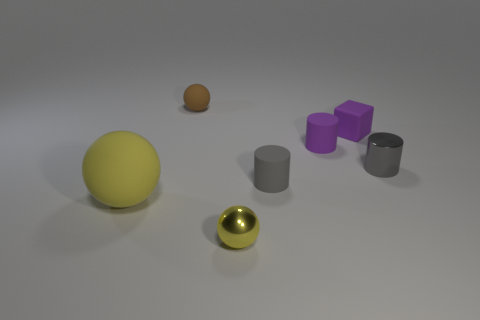There is a metallic thing right of the yellow object to the right of the brown object; what color is it?
Your answer should be very brief. Gray. Is there anything else that has the same shape as the large yellow rubber object?
Keep it short and to the point. Yes. Is the number of tiny purple cylinders that are to the left of the large matte ball the same as the number of small cylinders that are behind the metal cylinder?
Offer a very short reply. No. How many cylinders are tiny gray things or tiny yellow metallic things?
Ensure brevity in your answer.  2. How many other objects are there of the same material as the large object?
Your answer should be very brief. 4. There is a tiny metallic object to the right of the small yellow metallic sphere; what is its shape?
Your answer should be compact. Cylinder. There is a yellow sphere that is to the left of the tiny ball that is in front of the large object; what is its material?
Ensure brevity in your answer.  Rubber. Is the number of yellow spheres to the left of the matte block greater than the number of tiny brown shiny things?
Your response must be concise. Yes. How many other objects are the same color as the small rubber cube?
Provide a short and direct response. 1. What shape is the gray shiny thing that is the same size as the brown thing?
Offer a very short reply. Cylinder. 